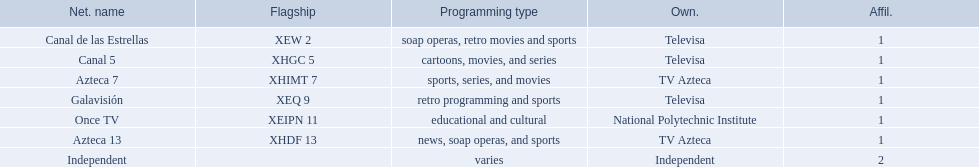What station shows cartoons? Canal 5. What station shows soap operas? Canal de las Estrellas. What station shows sports? Azteca 7. 